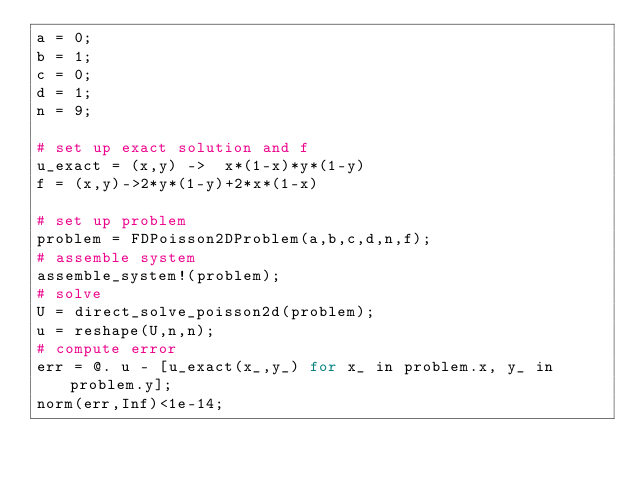<code> <loc_0><loc_0><loc_500><loc_500><_Julia_>a = 0;
b = 1;
c = 0;
d = 1;
n = 9;

# set up exact solution and f
u_exact = (x,y) ->  x*(1-x)*y*(1-y)
f = (x,y)->2*y*(1-y)+2*x*(1-x)

# set up problem
problem = FDPoisson2DProblem(a,b,c,d,n,f);
# assemble system
assemble_system!(problem);
# solve
U = direct_solve_poisson2d(problem);
u = reshape(U,n,n);
# compute error
err = @. u - [u_exact(x_,y_) for x_ in problem.x, y_ in problem.y];
norm(err,Inf)<1e-14;
</code> 